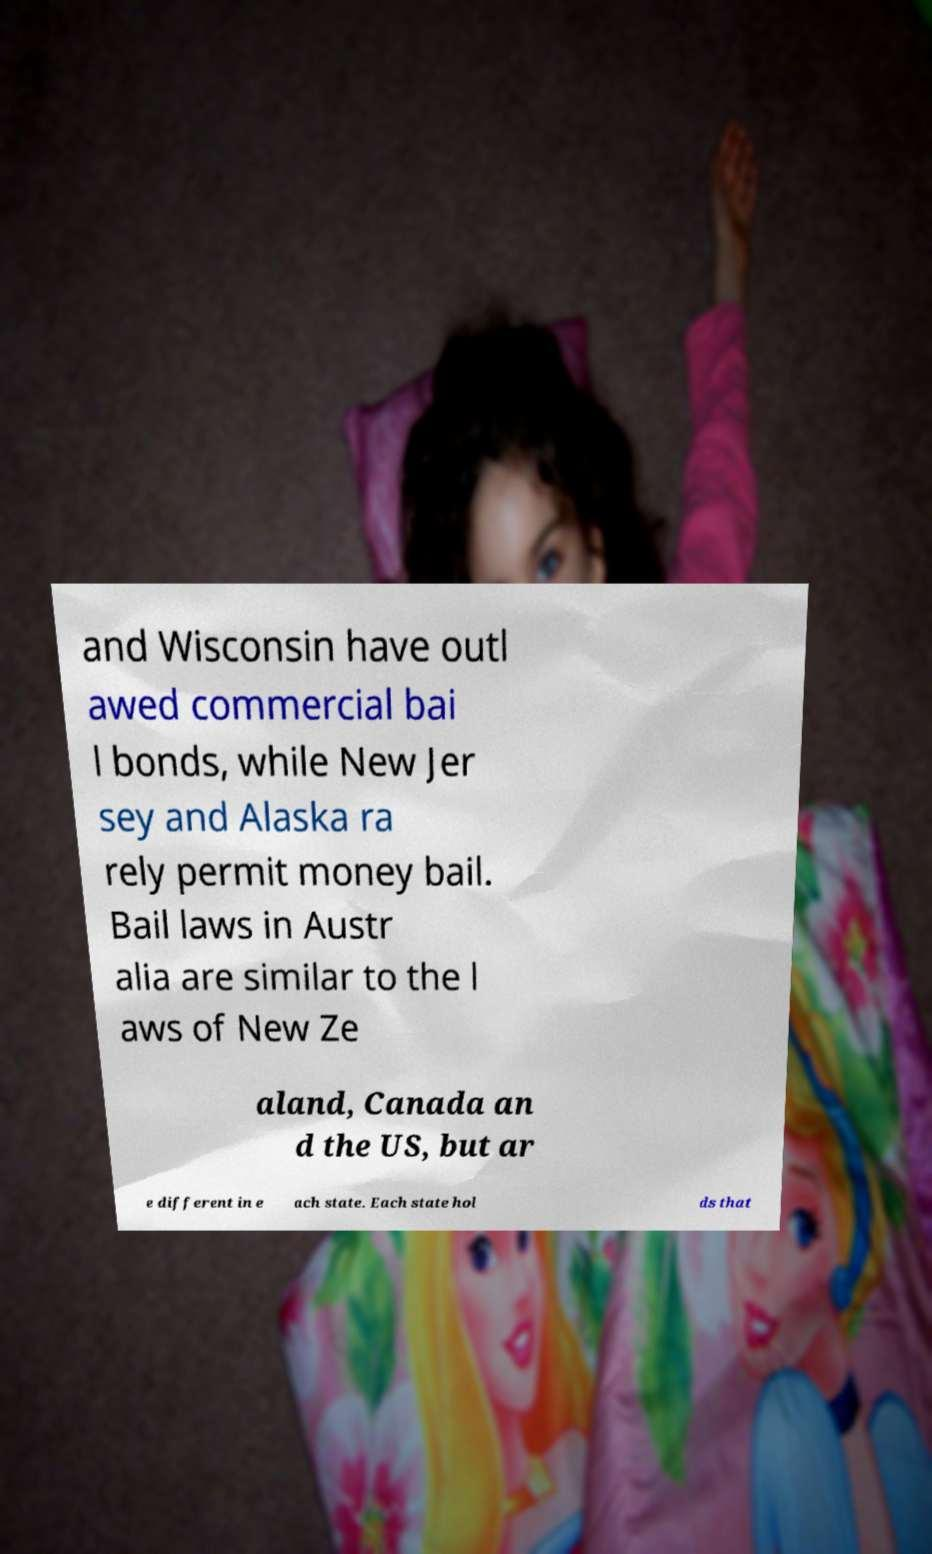There's text embedded in this image that I need extracted. Can you transcribe it verbatim? and Wisconsin have outl awed commercial bai l bonds, while New Jer sey and Alaska ra rely permit money bail. Bail laws in Austr alia are similar to the l aws of New Ze aland, Canada an d the US, but ar e different in e ach state. Each state hol ds that 